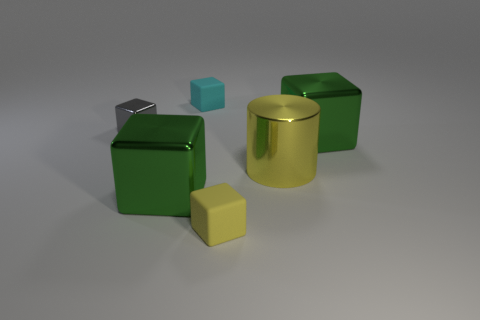Subtract all green metal blocks. How many blocks are left? 3 Add 1 small blue metallic cubes. How many objects exist? 7 Subtract all cubes. How many objects are left? 1 Subtract all brown balls. How many green blocks are left? 2 Subtract all cyan blocks. How many blocks are left? 4 Subtract 1 cylinders. How many cylinders are left? 0 Subtract all blue cubes. Subtract all green cylinders. How many cubes are left? 5 Subtract all tiny blocks. Subtract all large shiny blocks. How many objects are left? 1 Add 3 green metallic things. How many green metallic things are left? 5 Add 3 blue shiny blocks. How many blue shiny blocks exist? 3 